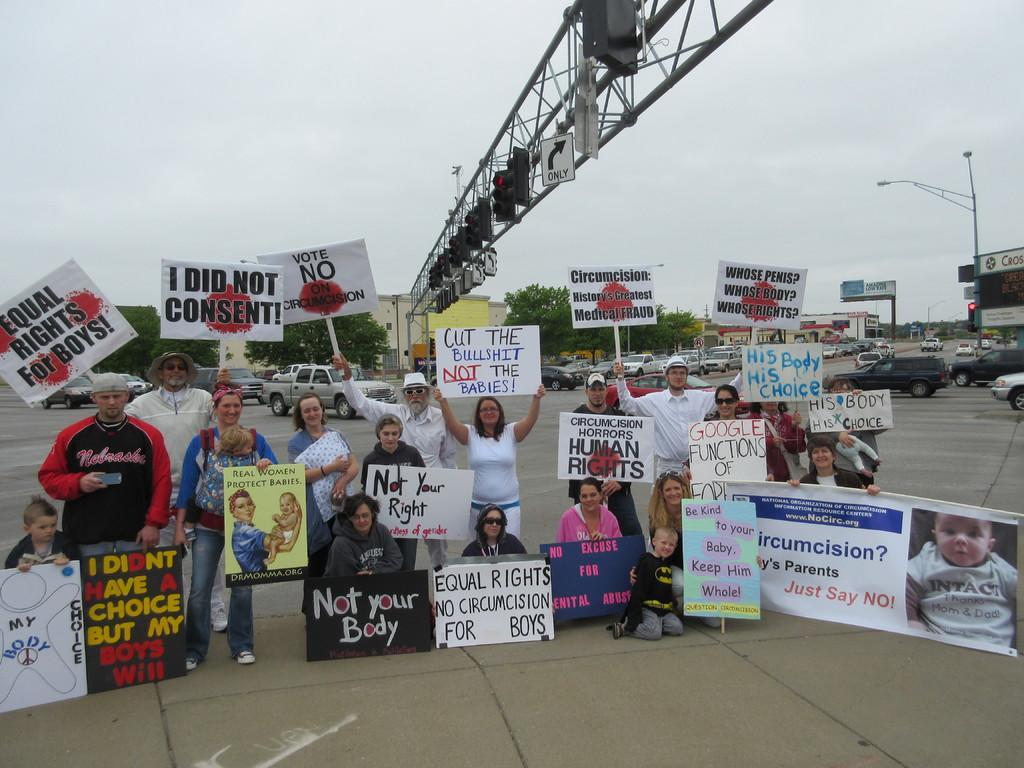Can you describe this image briefly? In this image, we can see some people holding the posters, we can see banners, there are some cars, we can see some signal lights, there are some trees, at the top we can see the sky. 